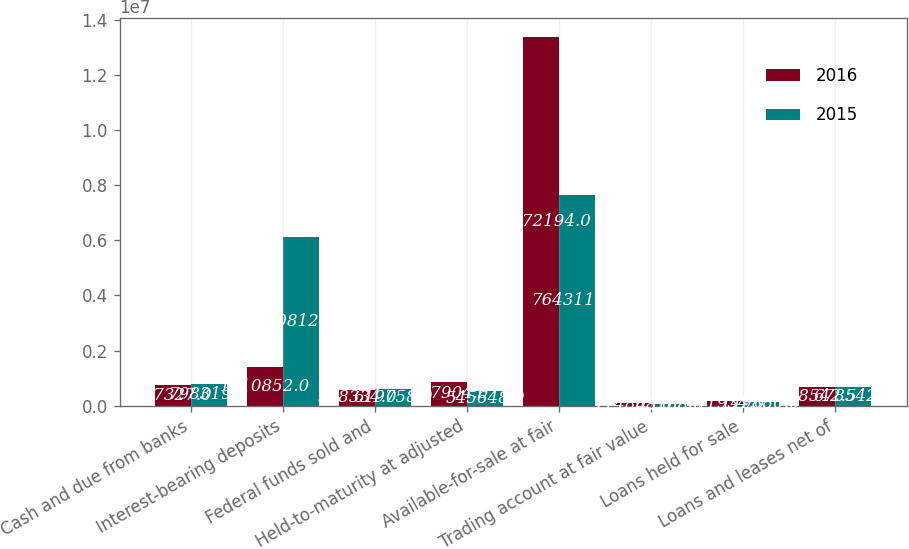Convert chart. <chart><loc_0><loc_0><loc_500><loc_500><stacked_bar_chart><ecel><fcel>Cash and due from banks<fcel>Interest-bearing deposits<fcel>Federal funds sold and<fcel>Held-to-maturity at adjusted<fcel>Available-for-sale at fair<fcel>Trading account at fair value<fcel>Loans held for sale<fcel>Loans and leases net of<nl><fcel>2016<fcel>737327<fcel>1.41085e+06<fcel>568334<fcel>867904<fcel>1.33722e+07<fcel>114803<fcel>171934<fcel>678542<nl><fcel>2015<fcel>798319<fcel>6.10812e+06<fcel>619758<fcel>545648<fcel>7.64312e+06<fcel>48168<fcel>149880<fcel>678542<nl></chart> 